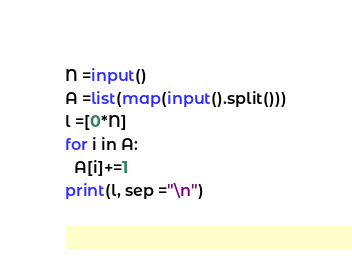Convert code to text. <code><loc_0><loc_0><loc_500><loc_500><_Python_>N =input()
A =list(map(input().split()))
l =[0*N]
for i in A:
  A[i]+=1
print(l, sep ="\n")
</code> 